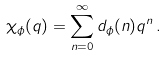<formula> <loc_0><loc_0><loc_500><loc_500>\chi _ { \phi } ( q ) = \sum _ { n = 0 } ^ { \infty } d _ { \phi } ( n ) q ^ { n } \, .</formula> 